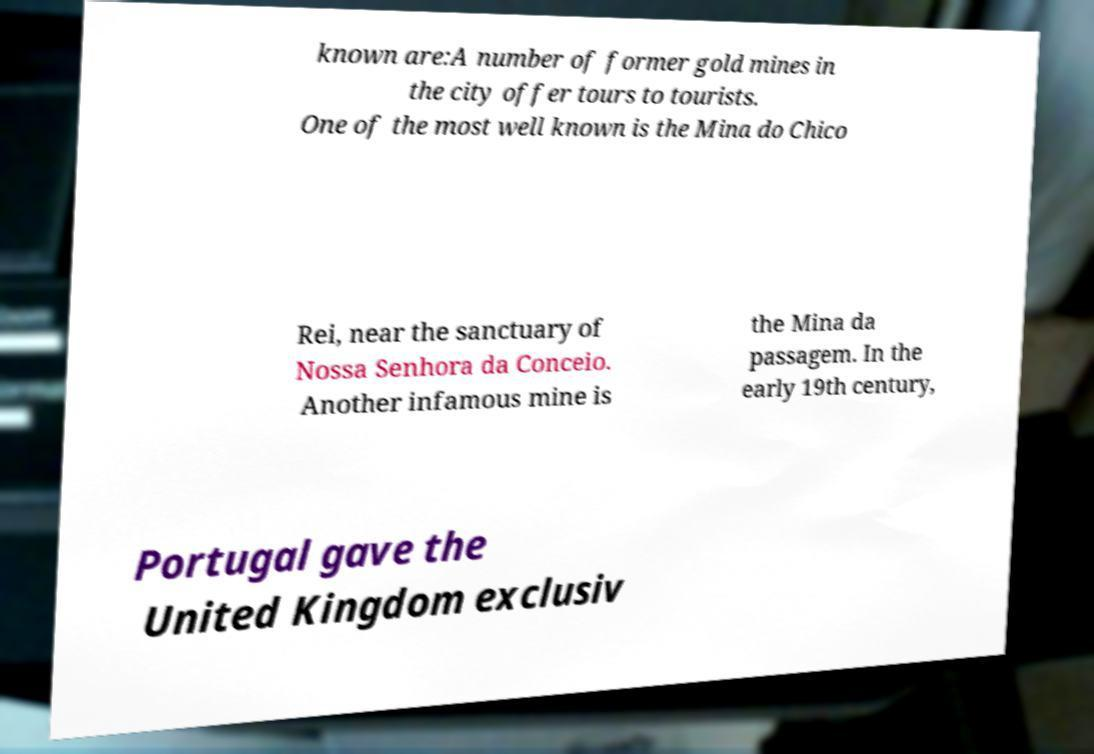Please identify and transcribe the text found in this image. known are:A number of former gold mines in the city offer tours to tourists. One of the most well known is the Mina do Chico Rei, near the sanctuary of Nossa Senhora da Conceio. Another infamous mine is the Mina da passagem. In the early 19th century, Portugal gave the United Kingdom exclusiv 